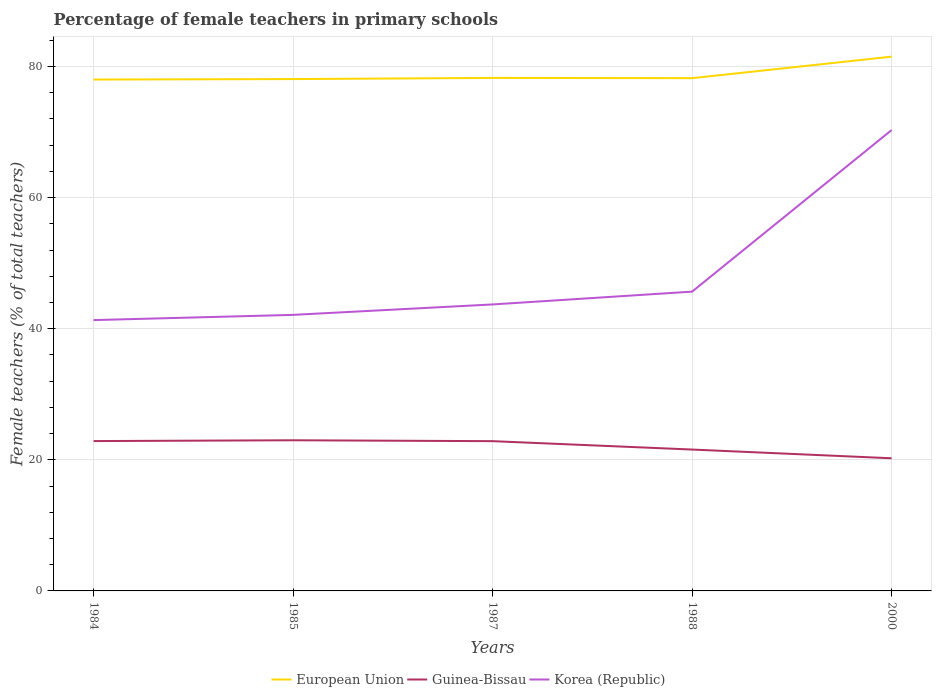Does the line corresponding to European Union intersect with the line corresponding to Korea (Republic)?
Offer a very short reply. No. Across all years, what is the maximum percentage of female teachers in European Union?
Offer a terse response. 78.01. What is the total percentage of female teachers in Korea (Republic) in the graph?
Make the answer very short. -28.19. What is the difference between the highest and the second highest percentage of female teachers in Guinea-Bissau?
Offer a terse response. 2.75. What is the difference between the highest and the lowest percentage of female teachers in Korea (Republic)?
Your answer should be compact. 1. Is the percentage of female teachers in Guinea-Bissau strictly greater than the percentage of female teachers in European Union over the years?
Make the answer very short. Yes. How many lines are there?
Your answer should be compact. 3. What is the difference between two consecutive major ticks on the Y-axis?
Make the answer very short. 20. Are the values on the major ticks of Y-axis written in scientific E-notation?
Your answer should be very brief. No. Where does the legend appear in the graph?
Your response must be concise. Bottom center. How many legend labels are there?
Offer a very short reply. 3. How are the legend labels stacked?
Provide a short and direct response. Horizontal. What is the title of the graph?
Ensure brevity in your answer.  Percentage of female teachers in primary schools. Does "Central Europe" appear as one of the legend labels in the graph?
Make the answer very short. No. What is the label or title of the Y-axis?
Your answer should be compact. Female teachers (% of total teachers). What is the Female teachers (% of total teachers) of European Union in 1984?
Your response must be concise. 78.01. What is the Female teachers (% of total teachers) of Guinea-Bissau in 1984?
Give a very brief answer. 22.86. What is the Female teachers (% of total teachers) of Korea (Republic) in 1984?
Ensure brevity in your answer.  41.31. What is the Female teachers (% of total teachers) of European Union in 1985?
Ensure brevity in your answer.  78.08. What is the Female teachers (% of total teachers) in Guinea-Bissau in 1985?
Offer a terse response. 22.98. What is the Female teachers (% of total teachers) in Korea (Republic) in 1985?
Provide a short and direct response. 42.11. What is the Female teachers (% of total teachers) of European Union in 1987?
Your answer should be compact. 78.26. What is the Female teachers (% of total teachers) of Guinea-Bissau in 1987?
Ensure brevity in your answer.  22.85. What is the Female teachers (% of total teachers) of Korea (Republic) in 1987?
Your answer should be very brief. 43.7. What is the Female teachers (% of total teachers) in European Union in 1988?
Provide a succinct answer. 78.22. What is the Female teachers (% of total teachers) in Guinea-Bissau in 1988?
Keep it short and to the point. 21.57. What is the Female teachers (% of total teachers) in Korea (Republic) in 1988?
Offer a terse response. 45.66. What is the Female teachers (% of total teachers) in European Union in 2000?
Offer a very short reply. 81.5. What is the Female teachers (% of total teachers) of Guinea-Bissau in 2000?
Offer a terse response. 20.23. What is the Female teachers (% of total teachers) of Korea (Republic) in 2000?
Offer a very short reply. 70.3. Across all years, what is the maximum Female teachers (% of total teachers) in European Union?
Provide a succinct answer. 81.5. Across all years, what is the maximum Female teachers (% of total teachers) of Guinea-Bissau?
Your answer should be very brief. 22.98. Across all years, what is the maximum Female teachers (% of total teachers) of Korea (Republic)?
Your response must be concise. 70.3. Across all years, what is the minimum Female teachers (% of total teachers) of European Union?
Make the answer very short. 78.01. Across all years, what is the minimum Female teachers (% of total teachers) of Guinea-Bissau?
Provide a short and direct response. 20.23. Across all years, what is the minimum Female teachers (% of total teachers) in Korea (Republic)?
Offer a very short reply. 41.31. What is the total Female teachers (% of total teachers) of European Union in the graph?
Offer a terse response. 394.07. What is the total Female teachers (% of total teachers) in Guinea-Bissau in the graph?
Offer a very short reply. 110.49. What is the total Female teachers (% of total teachers) of Korea (Republic) in the graph?
Offer a terse response. 243.09. What is the difference between the Female teachers (% of total teachers) in European Union in 1984 and that in 1985?
Provide a succinct answer. -0.07. What is the difference between the Female teachers (% of total teachers) of Guinea-Bissau in 1984 and that in 1985?
Your answer should be compact. -0.12. What is the difference between the Female teachers (% of total teachers) of Korea (Republic) in 1984 and that in 1985?
Offer a terse response. -0.8. What is the difference between the Female teachers (% of total teachers) of European Union in 1984 and that in 1987?
Offer a terse response. -0.25. What is the difference between the Female teachers (% of total teachers) in Guinea-Bissau in 1984 and that in 1987?
Ensure brevity in your answer.  0.01. What is the difference between the Female teachers (% of total teachers) of Korea (Republic) in 1984 and that in 1987?
Keep it short and to the point. -2.39. What is the difference between the Female teachers (% of total teachers) of European Union in 1984 and that in 1988?
Ensure brevity in your answer.  -0.21. What is the difference between the Female teachers (% of total teachers) in Guinea-Bissau in 1984 and that in 1988?
Provide a short and direct response. 1.29. What is the difference between the Female teachers (% of total teachers) of Korea (Republic) in 1984 and that in 1988?
Ensure brevity in your answer.  -4.34. What is the difference between the Female teachers (% of total teachers) of European Union in 1984 and that in 2000?
Your response must be concise. -3.49. What is the difference between the Female teachers (% of total teachers) of Guinea-Bissau in 1984 and that in 2000?
Offer a very short reply. 2.62. What is the difference between the Female teachers (% of total teachers) in Korea (Republic) in 1984 and that in 2000?
Keep it short and to the point. -28.99. What is the difference between the Female teachers (% of total teachers) in European Union in 1985 and that in 1987?
Provide a short and direct response. -0.17. What is the difference between the Female teachers (% of total teachers) in Guinea-Bissau in 1985 and that in 1987?
Provide a short and direct response. 0.14. What is the difference between the Female teachers (% of total teachers) in Korea (Republic) in 1985 and that in 1987?
Ensure brevity in your answer.  -1.59. What is the difference between the Female teachers (% of total teachers) of European Union in 1985 and that in 1988?
Give a very brief answer. -0.14. What is the difference between the Female teachers (% of total teachers) in Guinea-Bissau in 1985 and that in 1988?
Your answer should be compact. 1.42. What is the difference between the Female teachers (% of total teachers) in Korea (Republic) in 1985 and that in 1988?
Provide a short and direct response. -3.54. What is the difference between the Female teachers (% of total teachers) of European Union in 1985 and that in 2000?
Ensure brevity in your answer.  -3.42. What is the difference between the Female teachers (% of total teachers) of Guinea-Bissau in 1985 and that in 2000?
Make the answer very short. 2.75. What is the difference between the Female teachers (% of total teachers) in Korea (Republic) in 1985 and that in 2000?
Make the answer very short. -28.19. What is the difference between the Female teachers (% of total teachers) in European Union in 1987 and that in 1988?
Ensure brevity in your answer.  0.04. What is the difference between the Female teachers (% of total teachers) of Guinea-Bissau in 1987 and that in 1988?
Your response must be concise. 1.28. What is the difference between the Female teachers (% of total teachers) in Korea (Republic) in 1987 and that in 1988?
Provide a succinct answer. -1.95. What is the difference between the Female teachers (% of total teachers) in European Union in 1987 and that in 2000?
Your answer should be compact. -3.24. What is the difference between the Female teachers (% of total teachers) of Guinea-Bissau in 1987 and that in 2000?
Your answer should be compact. 2.61. What is the difference between the Female teachers (% of total teachers) in Korea (Republic) in 1987 and that in 2000?
Provide a short and direct response. -26.6. What is the difference between the Female teachers (% of total teachers) of European Union in 1988 and that in 2000?
Offer a very short reply. -3.28. What is the difference between the Female teachers (% of total teachers) of Guinea-Bissau in 1988 and that in 2000?
Keep it short and to the point. 1.33. What is the difference between the Female teachers (% of total teachers) of Korea (Republic) in 1988 and that in 2000?
Keep it short and to the point. -24.65. What is the difference between the Female teachers (% of total teachers) of European Union in 1984 and the Female teachers (% of total teachers) of Guinea-Bissau in 1985?
Your answer should be compact. 55.03. What is the difference between the Female teachers (% of total teachers) in European Union in 1984 and the Female teachers (% of total teachers) in Korea (Republic) in 1985?
Keep it short and to the point. 35.9. What is the difference between the Female teachers (% of total teachers) of Guinea-Bissau in 1984 and the Female teachers (% of total teachers) of Korea (Republic) in 1985?
Keep it short and to the point. -19.25. What is the difference between the Female teachers (% of total teachers) in European Union in 1984 and the Female teachers (% of total teachers) in Guinea-Bissau in 1987?
Offer a very short reply. 55.16. What is the difference between the Female teachers (% of total teachers) of European Union in 1984 and the Female teachers (% of total teachers) of Korea (Republic) in 1987?
Ensure brevity in your answer.  34.31. What is the difference between the Female teachers (% of total teachers) of Guinea-Bissau in 1984 and the Female teachers (% of total teachers) of Korea (Republic) in 1987?
Offer a very short reply. -20.84. What is the difference between the Female teachers (% of total teachers) in European Union in 1984 and the Female teachers (% of total teachers) in Guinea-Bissau in 1988?
Your answer should be very brief. 56.44. What is the difference between the Female teachers (% of total teachers) in European Union in 1984 and the Female teachers (% of total teachers) in Korea (Republic) in 1988?
Keep it short and to the point. 32.35. What is the difference between the Female teachers (% of total teachers) of Guinea-Bissau in 1984 and the Female teachers (% of total teachers) of Korea (Republic) in 1988?
Ensure brevity in your answer.  -22.8. What is the difference between the Female teachers (% of total teachers) of European Union in 1984 and the Female teachers (% of total teachers) of Guinea-Bissau in 2000?
Provide a short and direct response. 57.77. What is the difference between the Female teachers (% of total teachers) in European Union in 1984 and the Female teachers (% of total teachers) in Korea (Republic) in 2000?
Make the answer very short. 7.71. What is the difference between the Female teachers (% of total teachers) in Guinea-Bissau in 1984 and the Female teachers (% of total teachers) in Korea (Republic) in 2000?
Provide a succinct answer. -47.44. What is the difference between the Female teachers (% of total teachers) of European Union in 1985 and the Female teachers (% of total teachers) of Guinea-Bissau in 1987?
Your response must be concise. 55.24. What is the difference between the Female teachers (% of total teachers) in European Union in 1985 and the Female teachers (% of total teachers) in Korea (Republic) in 1987?
Offer a terse response. 34.38. What is the difference between the Female teachers (% of total teachers) in Guinea-Bissau in 1985 and the Female teachers (% of total teachers) in Korea (Republic) in 1987?
Provide a short and direct response. -20.72. What is the difference between the Female teachers (% of total teachers) in European Union in 1985 and the Female teachers (% of total teachers) in Guinea-Bissau in 1988?
Keep it short and to the point. 56.52. What is the difference between the Female teachers (% of total teachers) in European Union in 1985 and the Female teachers (% of total teachers) in Korea (Republic) in 1988?
Give a very brief answer. 32.43. What is the difference between the Female teachers (% of total teachers) of Guinea-Bissau in 1985 and the Female teachers (% of total teachers) of Korea (Republic) in 1988?
Make the answer very short. -22.67. What is the difference between the Female teachers (% of total teachers) of European Union in 1985 and the Female teachers (% of total teachers) of Guinea-Bissau in 2000?
Provide a short and direct response. 57.85. What is the difference between the Female teachers (% of total teachers) of European Union in 1985 and the Female teachers (% of total teachers) of Korea (Republic) in 2000?
Ensure brevity in your answer.  7.78. What is the difference between the Female teachers (% of total teachers) of Guinea-Bissau in 1985 and the Female teachers (% of total teachers) of Korea (Republic) in 2000?
Give a very brief answer. -47.32. What is the difference between the Female teachers (% of total teachers) in European Union in 1987 and the Female teachers (% of total teachers) in Guinea-Bissau in 1988?
Ensure brevity in your answer.  56.69. What is the difference between the Female teachers (% of total teachers) in European Union in 1987 and the Female teachers (% of total teachers) in Korea (Republic) in 1988?
Your answer should be very brief. 32.6. What is the difference between the Female teachers (% of total teachers) of Guinea-Bissau in 1987 and the Female teachers (% of total teachers) of Korea (Republic) in 1988?
Provide a succinct answer. -22.81. What is the difference between the Female teachers (% of total teachers) of European Union in 1987 and the Female teachers (% of total teachers) of Guinea-Bissau in 2000?
Your response must be concise. 58.02. What is the difference between the Female teachers (% of total teachers) in European Union in 1987 and the Female teachers (% of total teachers) in Korea (Republic) in 2000?
Offer a very short reply. 7.95. What is the difference between the Female teachers (% of total teachers) of Guinea-Bissau in 1987 and the Female teachers (% of total teachers) of Korea (Republic) in 2000?
Keep it short and to the point. -47.46. What is the difference between the Female teachers (% of total teachers) of European Union in 1988 and the Female teachers (% of total teachers) of Guinea-Bissau in 2000?
Your answer should be compact. 57.98. What is the difference between the Female teachers (% of total teachers) in European Union in 1988 and the Female teachers (% of total teachers) in Korea (Republic) in 2000?
Make the answer very short. 7.92. What is the difference between the Female teachers (% of total teachers) in Guinea-Bissau in 1988 and the Female teachers (% of total teachers) in Korea (Republic) in 2000?
Your answer should be very brief. -48.74. What is the average Female teachers (% of total teachers) of European Union per year?
Make the answer very short. 78.81. What is the average Female teachers (% of total teachers) in Guinea-Bissau per year?
Your response must be concise. 22.1. What is the average Female teachers (% of total teachers) in Korea (Republic) per year?
Offer a very short reply. 48.62. In the year 1984, what is the difference between the Female teachers (% of total teachers) of European Union and Female teachers (% of total teachers) of Guinea-Bissau?
Keep it short and to the point. 55.15. In the year 1984, what is the difference between the Female teachers (% of total teachers) in European Union and Female teachers (% of total teachers) in Korea (Republic)?
Offer a terse response. 36.69. In the year 1984, what is the difference between the Female teachers (% of total teachers) in Guinea-Bissau and Female teachers (% of total teachers) in Korea (Republic)?
Provide a short and direct response. -18.46. In the year 1985, what is the difference between the Female teachers (% of total teachers) of European Union and Female teachers (% of total teachers) of Guinea-Bissau?
Offer a very short reply. 55.1. In the year 1985, what is the difference between the Female teachers (% of total teachers) of European Union and Female teachers (% of total teachers) of Korea (Republic)?
Your answer should be compact. 35.97. In the year 1985, what is the difference between the Female teachers (% of total teachers) of Guinea-Bissau and Female teachers (% of total teachers) of Korea (Republic)?
Your response must be concise. -19.13. In the year 1987, what is the difference between the Female teachers (% of total teachers) of European Union and Female teachers (% of total teachers) of Guinea-Bissau?
Provide a short and direct response. 55.41. In the year 1987, what is the difference between the Female teachers (% of total teachers) of European Union and Female teachers (% of total teachers) of Korea (Republic)?
Make the answer very short. 34.55. In the year 1987, what is the difference between the Female teachers (% of total teachers) of Guinea-Bissau and Female teachers (% of total teachers) of Korea (Republic)?
Provide a succinct answer. -20.86. In the year 1988, what is the difference between the Female teachers (% of total teachers) of European Union and Female teachers (% of total teachers) of Guinea-Bissau?
Offer a very short reply. 56.65. In the year 1988, what is the difference between the Female teachers (% of total teachers) of European Union and Female teachers (% of total teachers) of Korea (Republic)?
Your response must be concise. 32.56. In the year 1988, what is the difference between the Female teachers (% of total teachers) of Guinea-Bissau and Female teachers (% of total teachers) of Korea (Republic)?
Provide a succinct answer. -24.09. In the year 2000, what is the difference between the Female teachers (% of total teachers) of European Union and Female teachers (% of total teachers) of Guinea-Bissau?
Your response must be concise. 61.27. In the year 2000, what is the difference between the Female teachers (% of total teachers) of European Union and Female teachers (% of total teachers) of Korea (Republic)?
Offer a very short reply. 11.2. In the year 2000, what is the difference between the Female teachers (% of total teachers) of Guinea-Bissau and Female teachers (% of total teachers) of Korea (Republic)?
Your response must be concise. -50.07. What is the ratio of the Female teachers (% of total teachers) in Korea (Republic) in 1984 to that in 1985?
Make the answer very short. 0.98. What is the ratio of the Female teachers (% of total teachers) in European Union in 1984 to that in 1987?
Your answer should be very brief. 1. What is the ratio of the Female teachers (% of total teachers) in Guinea-Bissau in 1984 to that in 1987?
Make the answer very short. 1. What is the ratio of the Female teachers (% of total teachers) in Korea (Republic) in 1984 to that in 1987?
Give a very brief answer. 0.95. What is the ratio of the Female teachers (% of total teachers) in European Union in 1984 to that in 1988?
Offer a terse response. 1. What is the ratio of the Female teachers (% of total teachers) in Guinea-Bissau in 1984 to that in 1988?
Ensure brevity in your answer.  1.06. What is the ratio of the Female teachers (% of total teachers) of Korea (Republic) in 1984 to that in 1988?
Offer a terse response. 0.9. What is the ratio of the Female teachers (% of total teachers) of European Union in 1984 to that in 2000?
Keep it short and to the point. 0.96. What is the ratio of the Female teachers (% of total teachers) of Guinea-Bissau in 1984 to that in 2000?
Make the answer very short. 1.13. What is the ratio of the Female teachers (% of total teachers) of Korea (Republic) in 1984 to that in 2000?
Your answer should be compact. 0.59. What is the ratio of the Female teachers (% of total teachers) in European Union in 1985 to that in 1987?
Make the answer very short. 1. What is the ratio of the Female teachers (% of total teachers) of Guinea-Bissau in 1985 to that in 1987?
Provide a succinct answer. 1.01. What is the ratio of the Female teachers (% of total teachers) in Korea (Republic) in 1985 to that in 1987?
Give a very brief answer. 0.96. What is the ratio of the Female teachers (% of total teachers) of Guinea-Bissau in 1985 to that in 1988?
Your answer should be compact. 1.07. What is the ratio of the Female teachers (% of total teachers) of Korea (Republic) in 1985 to that in 1988?
Your answer should be compact. 0.92. What is the ratio of the Female teachers (% of total teachers) in European Union in 1985 to that in 2000?
Your answer should be very brief. 0.96. What is the ratio of the Female teachers (% of total teachers) of Guinea-Bissau in 1985 to that in 2000?
Provide a short and direct response. 1.14. What is the ratio of the Female teachers (% of total teachers) in Korea (Republic) in 1985 to that in 2000?
Provide a short and direct response. 0.6. What is the ratio of the Female teachers (% of total teachers) of European Union in 1987 to that in 1988?
Your response must be concise. 1. What is the ratio of the Female teachers (% of total teachers) of Guinea-Bissau in 1987 to that in 1988?
Your answer should be very brief. 1.06. What is the ratio of the Female teachers (% of total teachers) in Korea (Republic) in 1987 to that in 1988?
Ensure brevity in your answer.  0.96. What is the ratio of the Female teachers (% of total teachers) in European Union in 1987 to that in 2000?
Your answer should be compact. 0.96. What is the ratio of the Female teachers (% of total teachers) of Guinea-Bissau in 1987 to that in 2000?
Offer a very short reply. 1.13. What is the ratio of the Female teachers (% of total teachers) of Korea (Republic) in 1987 to that in 2000?
Your answer should be very brief. 0.62. What is the ratio of the Female teachers (% of total teachers) in European Union in 1988 to that in 2000?
Your answer should be compact. 0.96. What is the ratio of the Female teachers (% of total teachers) of Guinea-Bissau in 1988 to that in 2000?
Ensure brevity in your answer.  1.07. What is the ratio of the Female teachers (% of total teachers) of Korea (Republic) in 1988 to that in 2000?
Offer a terse response. 0.65. What is the difference between the highest and the second highest Female teachers (% of total teachers) in European Union?
Your answer should be very brief. 3.24. What is the difference between the highest and the second highest Female teachers (% of total teachers) in Guinea-Bissau?
Make the answer very short. 0.12. What is the difference between the highest and the second highest Female teachers (% of total teachers) in Korea (Republic)?
Provide a succinct answer. 24.65. What is the difference between the highest and the lowest Female teachers (% of total teachers) in European Union?
Make the answer very short. 3.49. What is the difference between the highest and the lowest Female teachers (% of total teachers) in Guinea-Bissau?
Offer a very short reply. 2.75. What is the difference between the highest and the lowest Female teachers (% of total teachers) of Korea (Republic)?
Give a very brief answer. 28.99. 